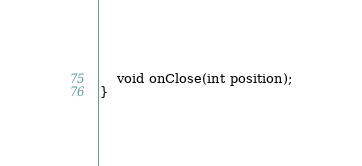<code> <loc_0><loc_0><loc_500><loc_500><_Java_>    void onClose(int position);
}</code> 